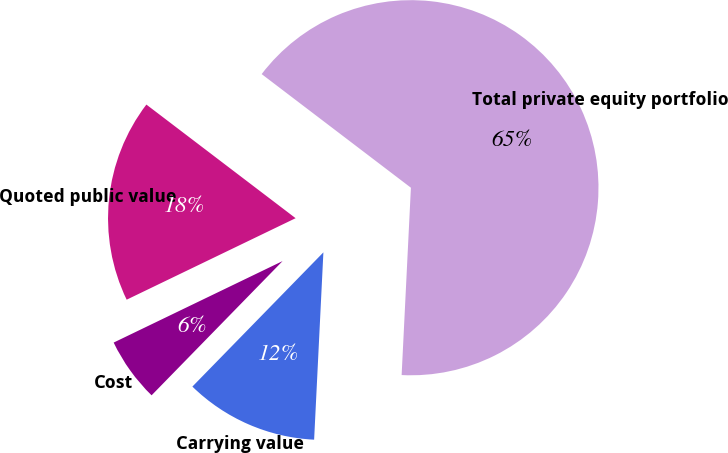Convert chart. <chart><loc_0><loc_0><loc_500><loc_500><pie_chart><fcel>Carrying value<fcel>Cost<fcel>Quoted public value<fcel>Total private equity portfolio<nl><fcel>11.52%<fcel>5.54%<fcel>17.51%<fcel>65.43%<nl></chart> 